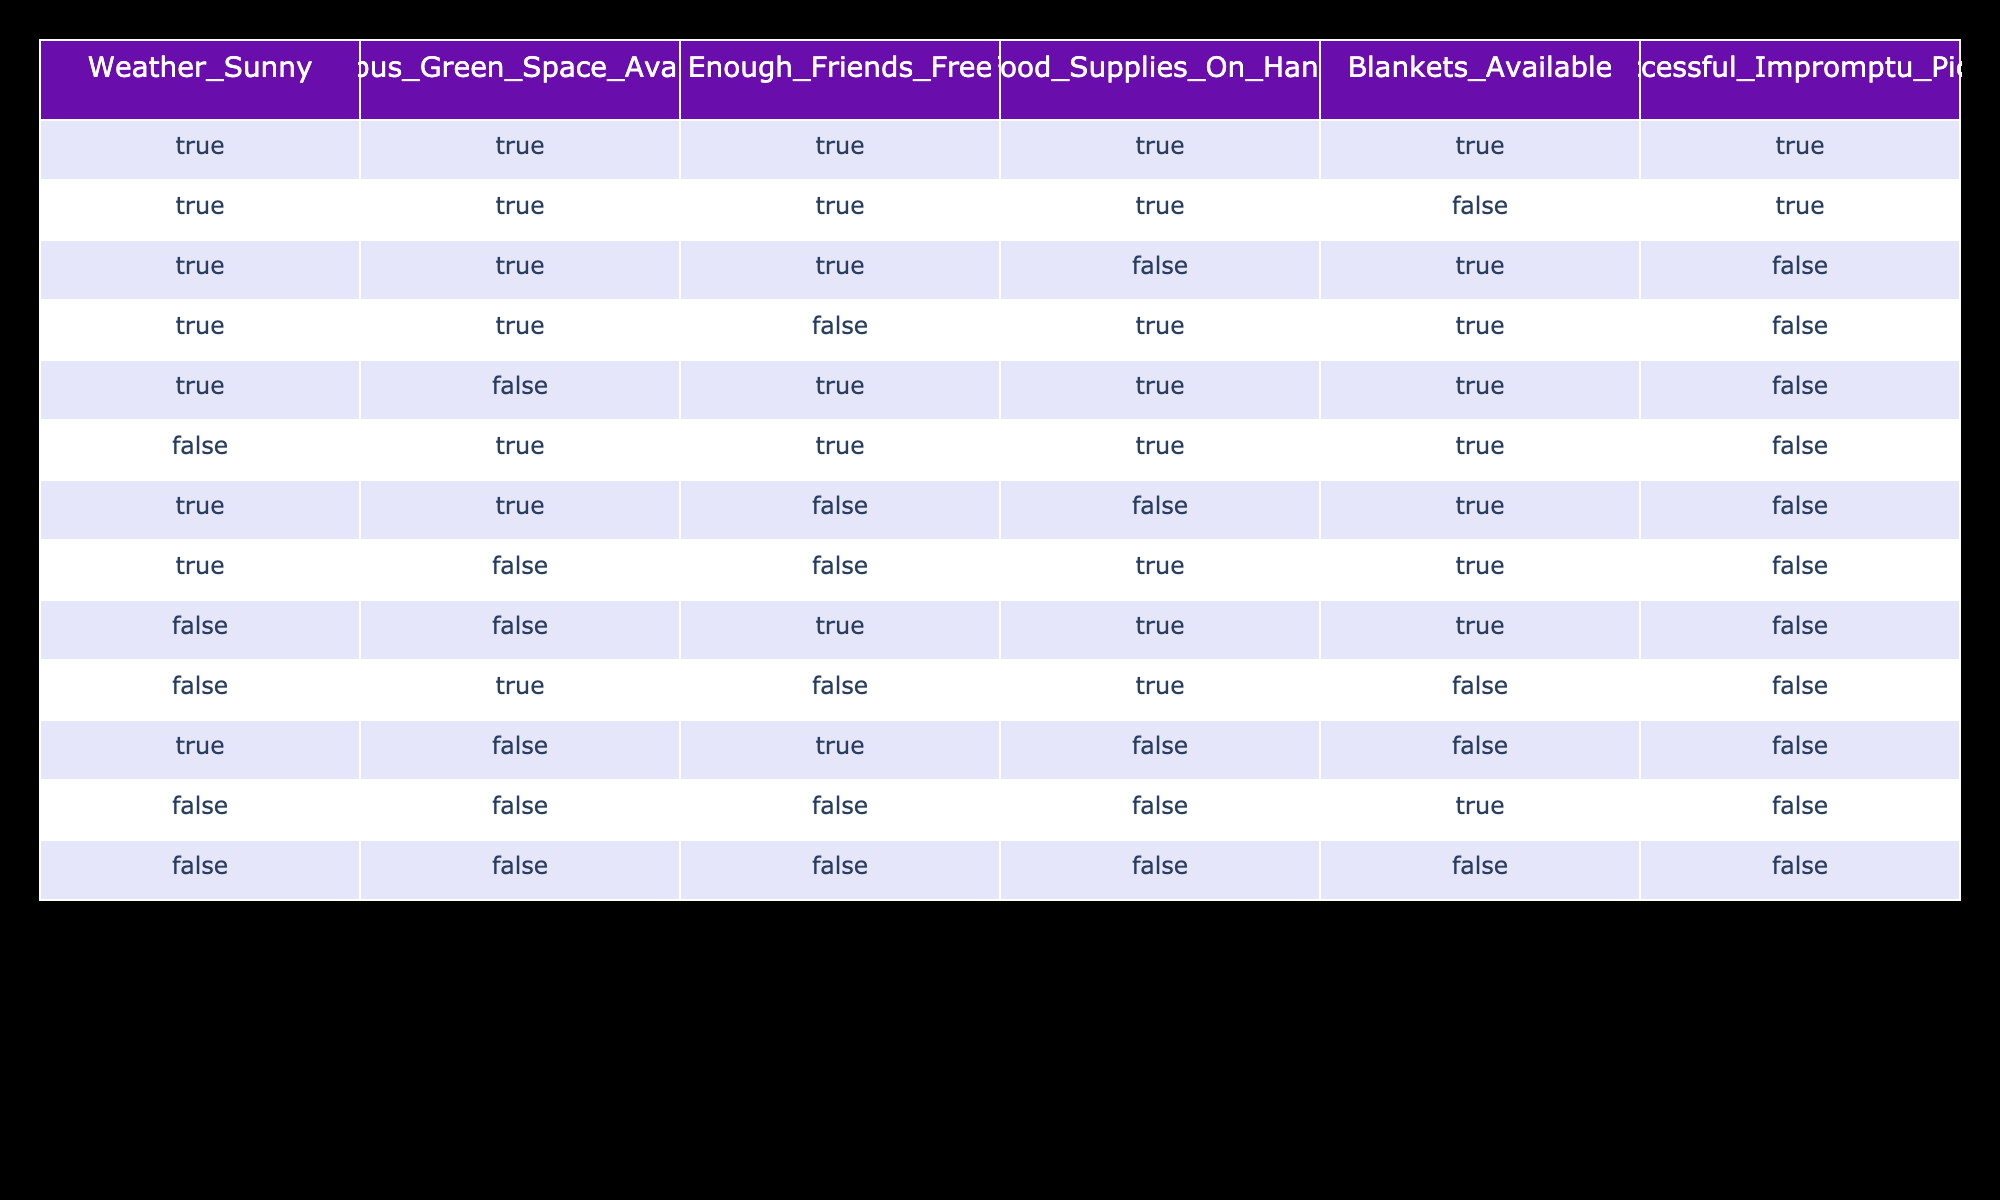What is the total number of successful impromptu picnics? By counting the rows in the table where the successful picnic column has a value of TRUE, we find that there are 2 rows that meet this criterion.
Answer: 2 How many rows show that the weather was sunny and enough friends were free? We look for rows where both the weather column is TRUE and the enough friends column is TRUE. There are 2 such rows (the first and second).
Answer: 2 Is it possible for a picnic to be successful with a blanket available but no food supplies? From the table, we see one row with blankets available (TRUE) and food supplies not on hand (FALSE) that is successful (TRUE). Therefore, yes, it can happen.
Answer: Yes What percentage of the picnics are unsuccessful? Out of the 14 total entries in the table, 12 are unsuccessful (rows marked FALSE). Therefore, the percentage calculated is (12/14) * 100, which simplifies to approximately 85.71%.
Answer: 85.71% If the green space is unavailable, how many successful picnics can still occur? Looking at the data, there are no rows with FALSE for the green space column where a picnic is successful. Thus, if the green space is unavailable, no successful picnics can occur.
Answer: 0 Are there any successful picnics with both food supplies present and blankets unavailable? We check the table for entries where food supplies are TRUE and blankets are FALSE. There is 1 row that fits this criteria, and it indicates an unsuccessful picnic. Therefore, the answer is no.
Answer: No How many picnics occurred when the weather was not sunny and there was a green space available? By reviewing the table, we find 3 rows where the weather is FALSE and the green space is TRUE.
Answer: 3 Considering only the successful picnics, how many had all supplies and friends available? When focusing on successful picnics defined by TRUE in the last column, there is only one instance where all other factors (friends, food, blankets) are also TRUE.
Answer: 1 